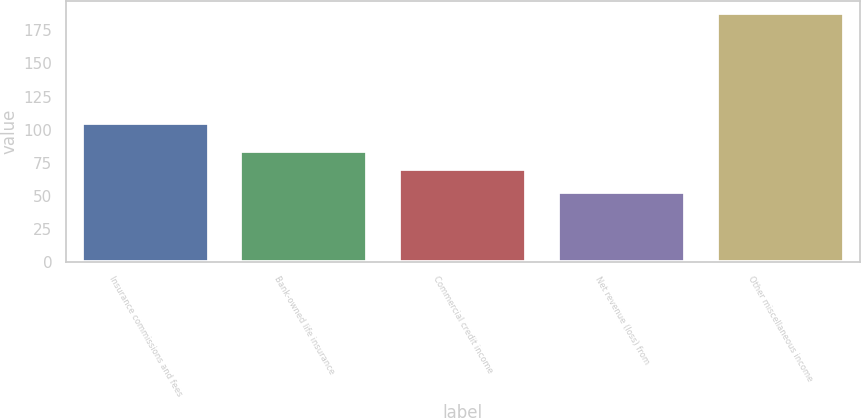Convert chart to OTSL. <chart><loc_0><loc_0><loc_500><loc_500><bar_chart><fcel>Insurance commissions and fees<fcel>Bank-owned life insurance<fcel>Commercial credit income<fcel>Net revenue (loss) from<fcel>Other miscellaneous income<nl><fcel>105<fcel>83.5<fcel>70<fcel>53<fcel>188<nl></chart> 